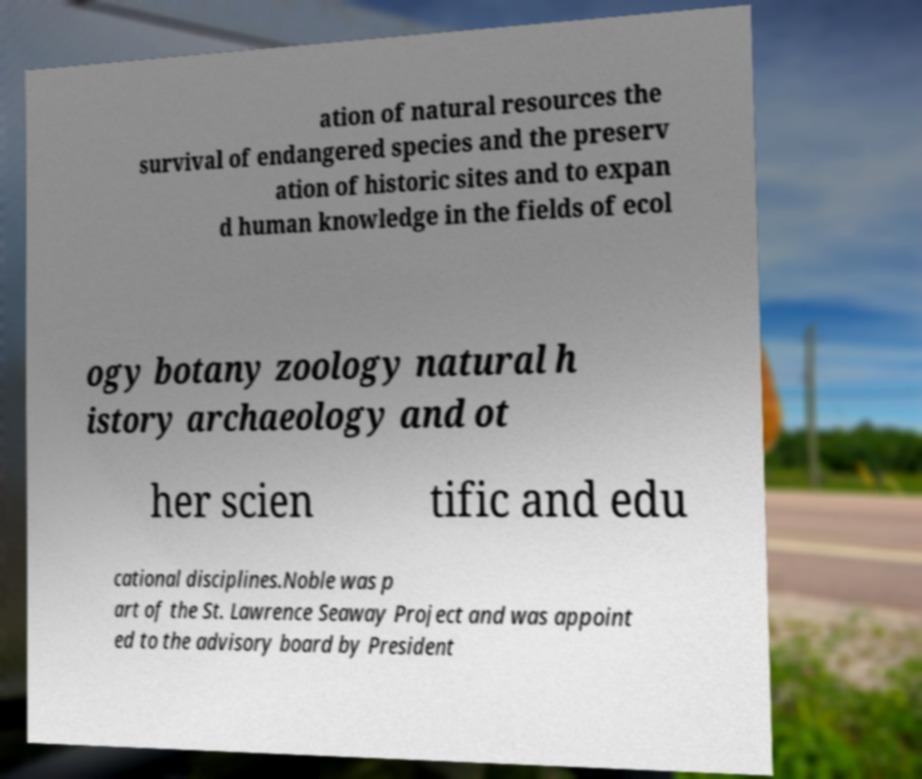What messages or text are displayed in this image? I need them in a readable, typed format. ation of natural resources the survival of endangered species and the preserv ation of historic sites and to expan d human knowledge in the fields of ecol ogy botany zoology natural h istory archaeology and ot her scien tific and edu cational disciplines.Noble was p art of the St. Lawrence Seaway Project and was appoint ed to the advisory board by President 